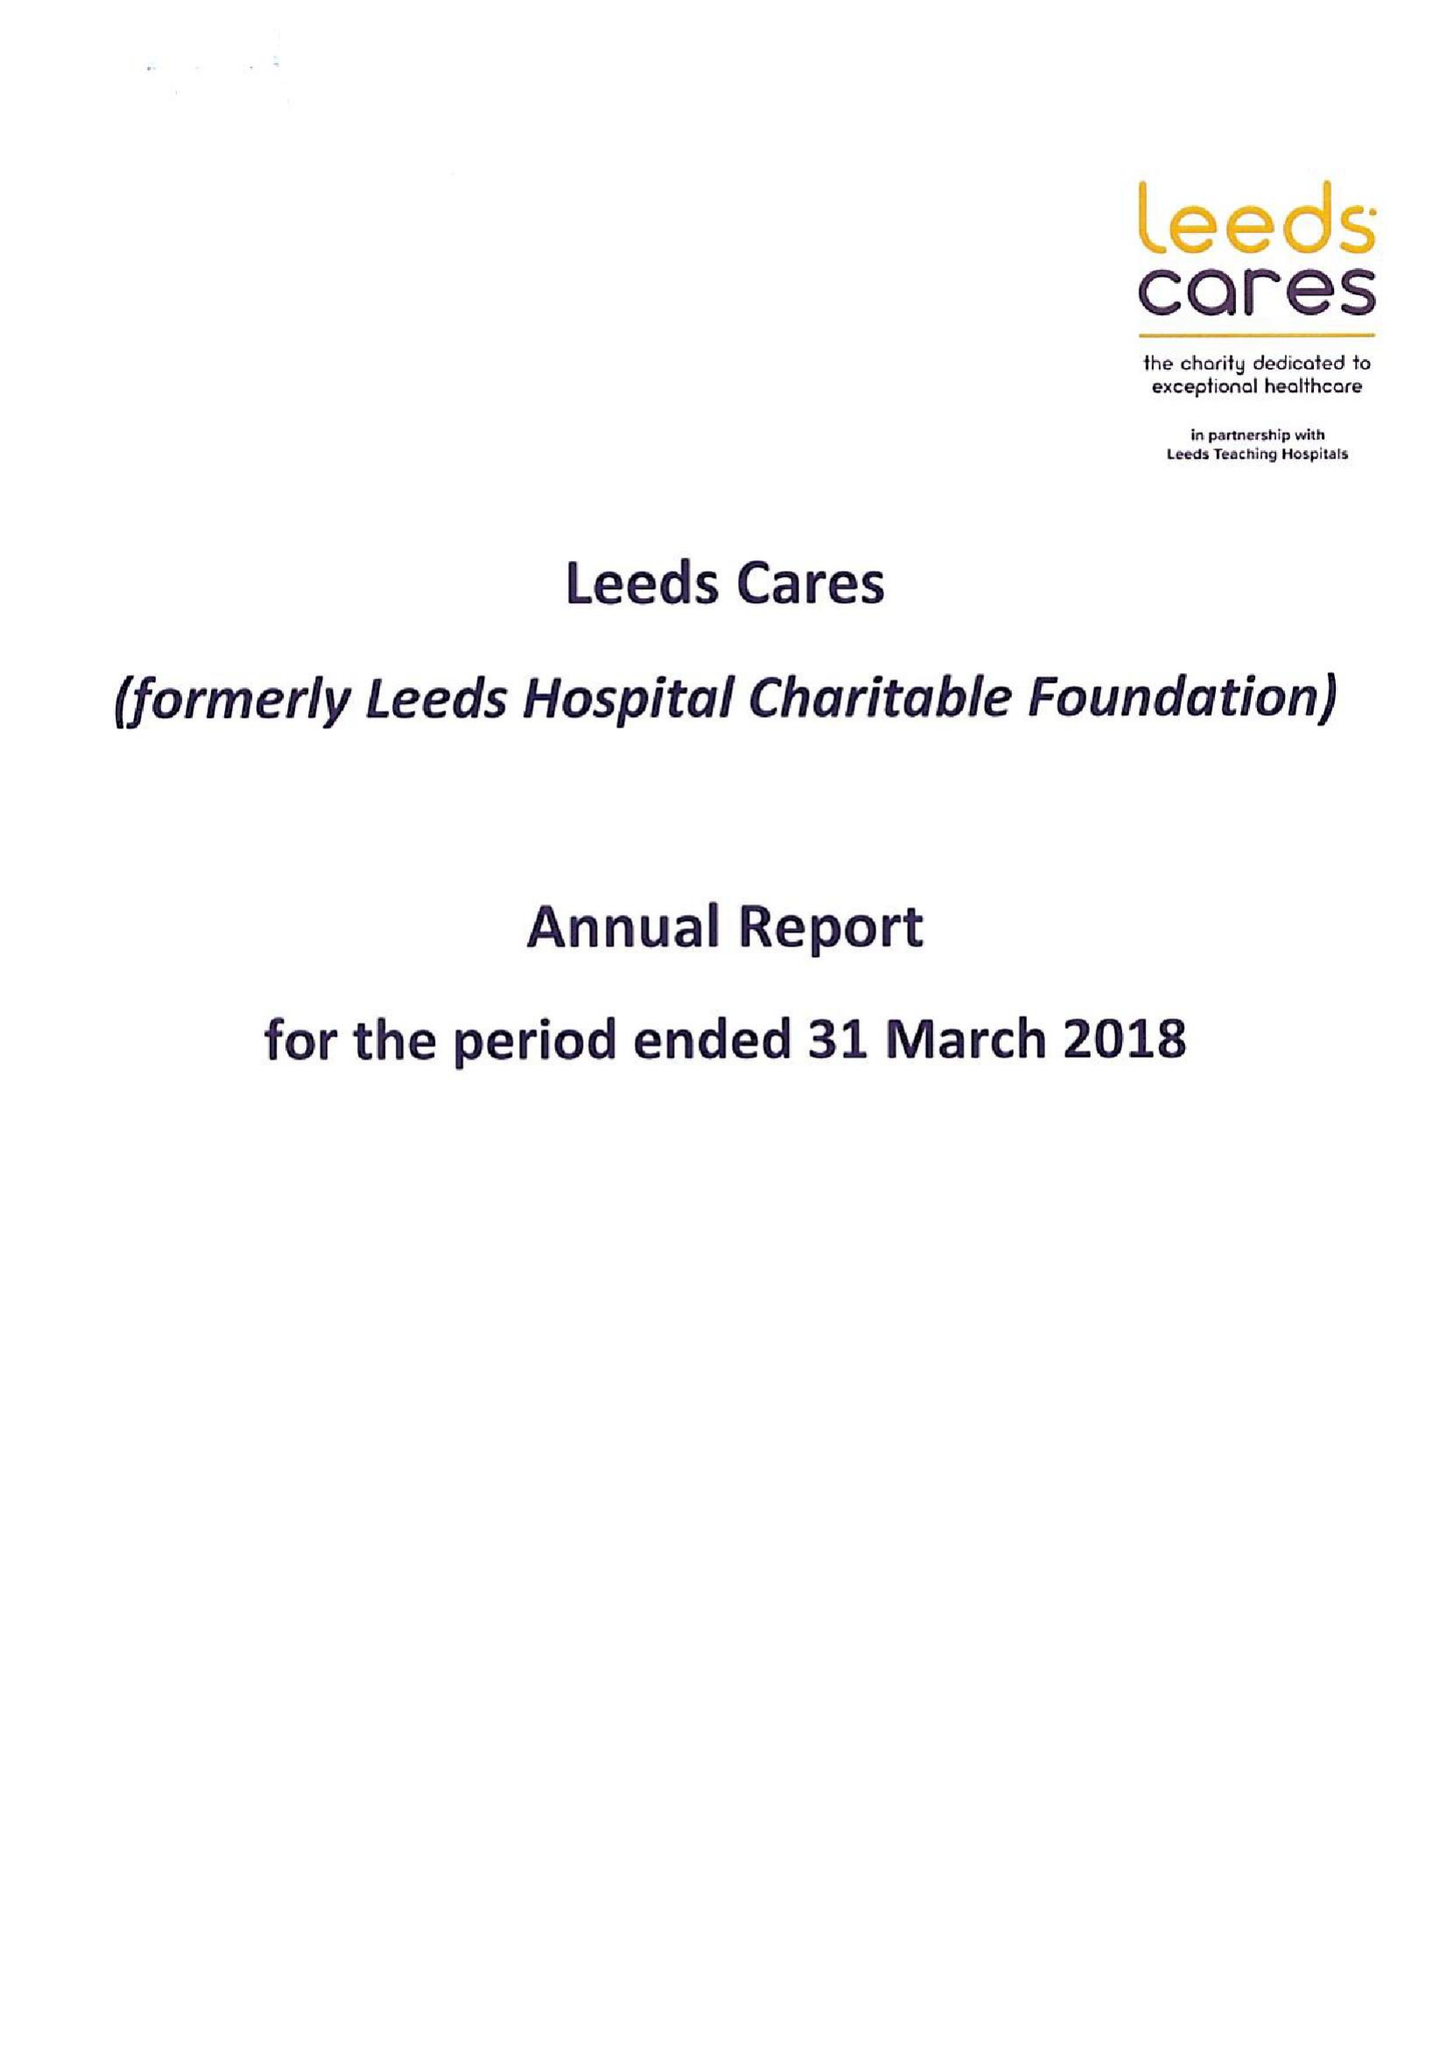What is the value for the charity_name?
Answer the question using a single word or phrase. Leeds Cares 